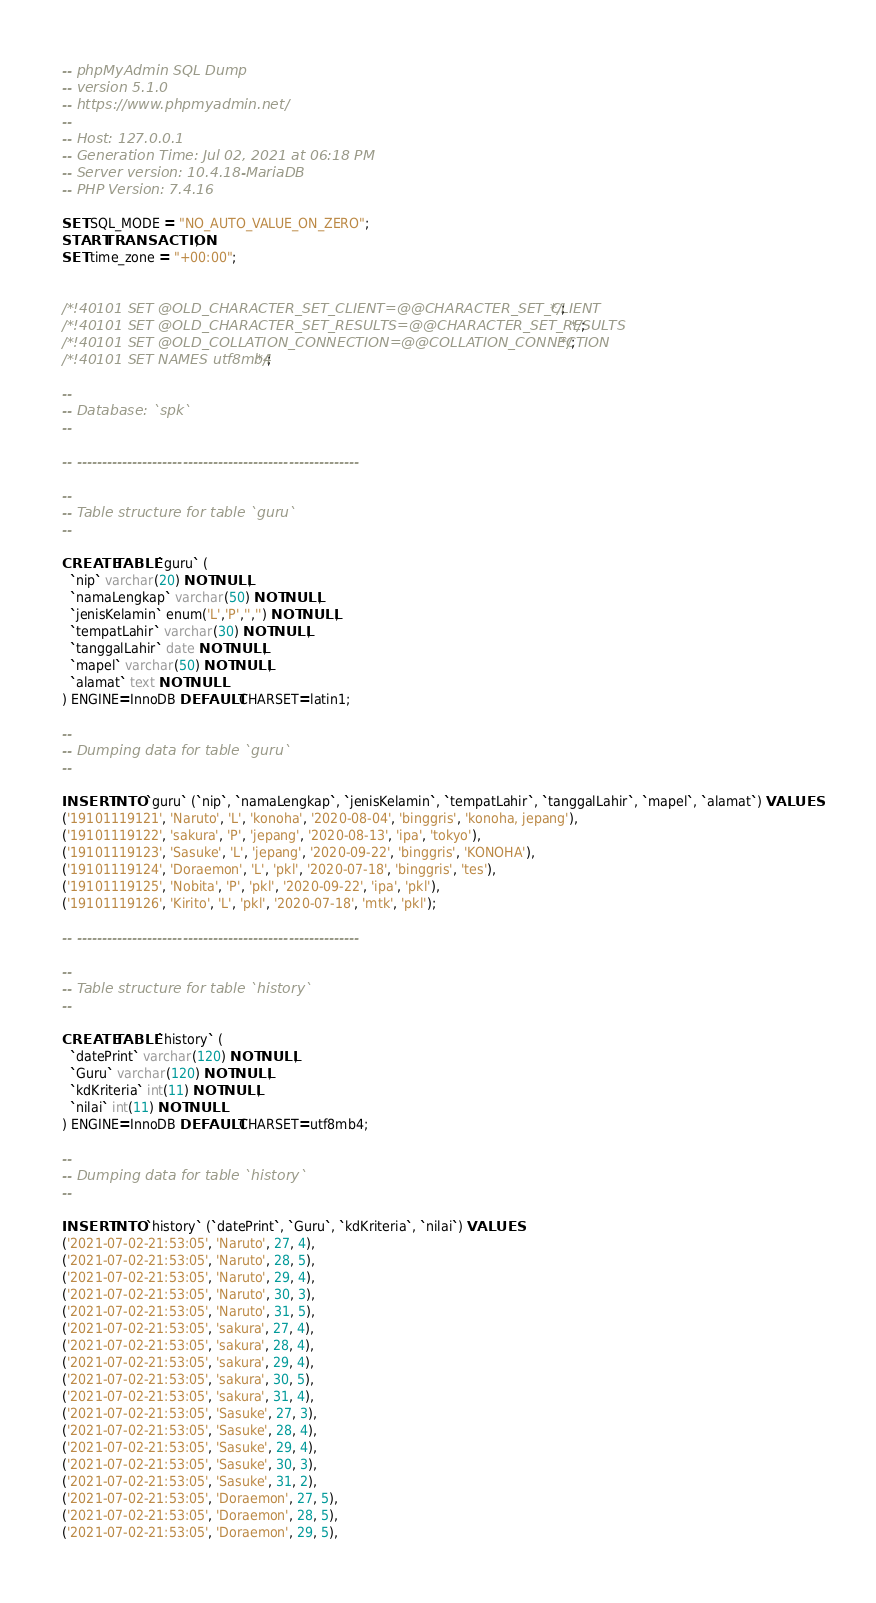Convert code to text. <code><loc_0><loc_0><loc_500><loc_500><_SQL_>-- phpMyAdmin SQL Dump
-- version 5.1.0
-- https://www.phpmyadmin.net/
--
-- Host: 127.0.0.1
-- Generation Time: Jul 02, 2021 at 06:18 PM
-- Server version: 10.4.18-MariaDB
-- PHP Version: 7.4.16

SET SQL_MODE = "NO_AUTO_VALUE_ON_ZERO";
START TRANSACTION;
SET time_zone = "+00:00";


/*!40101 SET @OLD_CHARACTER_SET_CLIENT=@@CHARACTER_SET_CLIENT */;
/*!40101 SET @OLD_CHARACTER_SET_RESULTS=@@CHARACTER_SET_RESULTS */;
/*!40101 SET @OLD_COLLATION_CONNECTION=@@COLLATION_CONNECTION */;
/*!40101 SET NAMES utf8mb4 */;

--
-- Database: `spk`
--

-- --------------------------------------------------------

--
-- Table structure for table `guru`
--

CREATE TABLE `guru` (
  `nip` varchar(20) NOT NULL,
  `namaLengkap` varchar(50) NOT NULL,
  `jenisKelamin` enum('L','P','','') NOT NULL,
  `tempatLahir` varchar(30) NOT NULL,
  `tanggalLahir` date NOT NULL,
  `mapel` varchar(50) NOT NULL,
  `alamat` text NOT NULL
) ENGINE=InnoDB DEFAULT CHARSET=latin1;

--
-- Dumping data for table `guru`
--

INSERT INTO `guru` (`nip`, `namaLengkap`, `jenisKelamin`, `tempatLahir`, `tanggalLahir`, `mapel`, `alamat`) VALUES
('19101119121', 'Naruto', 'L', 'konoha', '2020-08-04', 'binggris', 'konoha, jepang'),
('19101119122', 'sakura', 'P', 'jepang', '2020-08-13', 'ipa', 'tokyo'),
('19101119123', 'Sasuke', 'L', 'jepang', '2020-09-22', 'binggris', 'KONOHA'),
('19101119124', 'Doraemon', 'L', 'pkl', '2020-07-18', 'binggris', 'tes'),
('19101119125', 'Nobita', 'P', 'pkl', '2020-09-22', 'ipa', 'pkl'),
('19101119126', 'Kirito', 'L', 'pkl', '2020-07-18', 'mtk', 'pkl');

-- --------------------------------------------------------

--
-- Table structure for table `history`
--

CREATE TABLE `history` (
  `datePrint` varchar(120) NOT NULL,
  `Guru` varchar(120) NOT NULL,
  `kdKriteria` int(11) NOT NULL,
  `nilai` int(11) NOT NULL
) ENGINE=InnoDB DEFAULT CHARSET=utf8mb4;

--
-- Dumping data for table `history`
--

INSERT INTO `history` (`datePrint`, `Guru`, `kdKriteria`, `nilai`) VALUES
('2021-07-02-21:53:05', 'Naruto', 27, 4),
('2021-07-02-21:53:05', 'Naruto', 28, 5),
('2021-07-02-21:53:05', 'Naruto', 29, 4),
('2021-07-02-21:53:05', 'Naruto', 30, 3),
('2021-07-02-21:53:05', 'Naruto', 31, 5),
('2021-07-02-21:53:05', 'sakura', 27, 4),
('2021-07-02-21:53:05', 'sakura', 28, 4),
('2021-07-02-21:53:05', 'sakura', 29, 4),
('2021-07-02-21:53:05', 'sakura', 30, 5),
('2021-07-02-21:53:05', 'sakura', 31, 4),
('2021-07-02-21:53:05', 'Sasuke', 27, 3),
('2021-07-02-21:53:05', 'Sasuke', 28, 4),
('2021-07-02-21:53:05', 'Sasuke', 29, 4),
('2021-07-02-21:53:05', 'Sasuke', 30, 3),
('2021-07-02-21:53:05', 'Sasuke', 31, 2),
('2021-07-02-21:53:05', 'Doraemon', 27, 5),
('2021-07-02-21:53:05', 'Doraemon', 28, 5),
('2021-07-02-21:53:05', 'Doraemon', 29, 5),</code> 